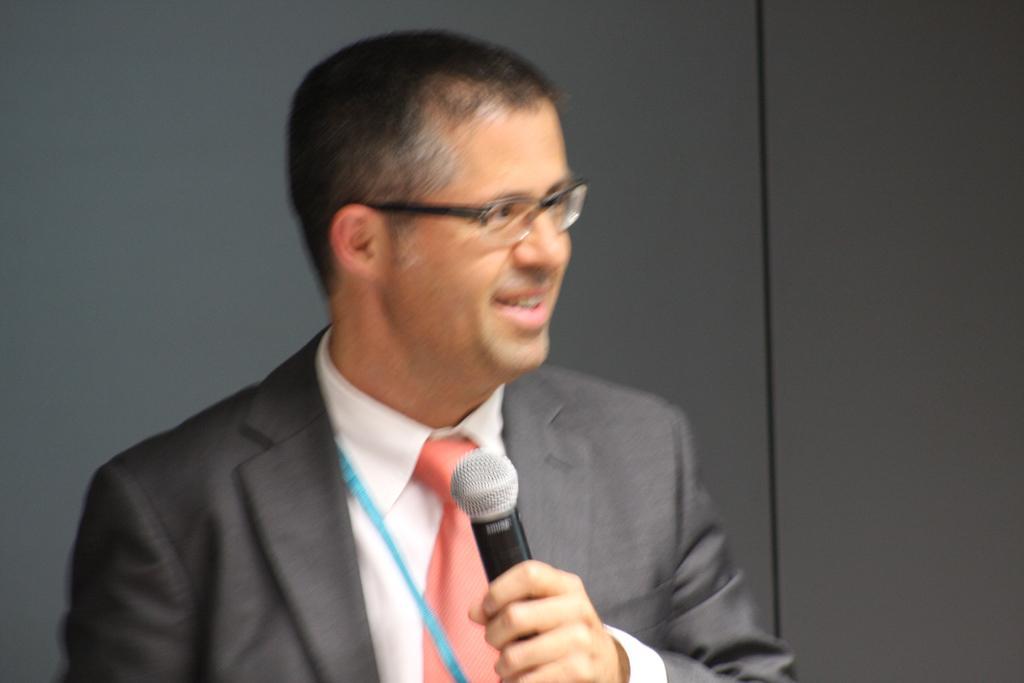How would you summarize this image in a sentence or two? In this picture we can see a man who is holding a mike with his hand. He is in suit and he has spectacles. 